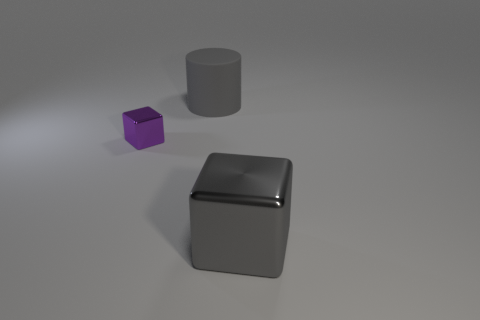Subtract all cubes. How many objects are left? 1 Add 3 big shiny objects. How many big shiny objects exist? 4 Add 1 tiny cubes. How many objects exist? 4 Subtract all gray cubes. How many cubes are left? 1 Subtract 0 green cylinders. How many objects are left? 3 Subtract all red cylinders. Subtract all purple balls. How many cylinders are left? 1 Subtract all brown cylinders. How many purple blocks are left? 1 Subtract all big metal blocks. Subtract all large gray metal cylinders. How many objects are left? 2 Add 2 gray matte things. How many gray matte things are left? 3 